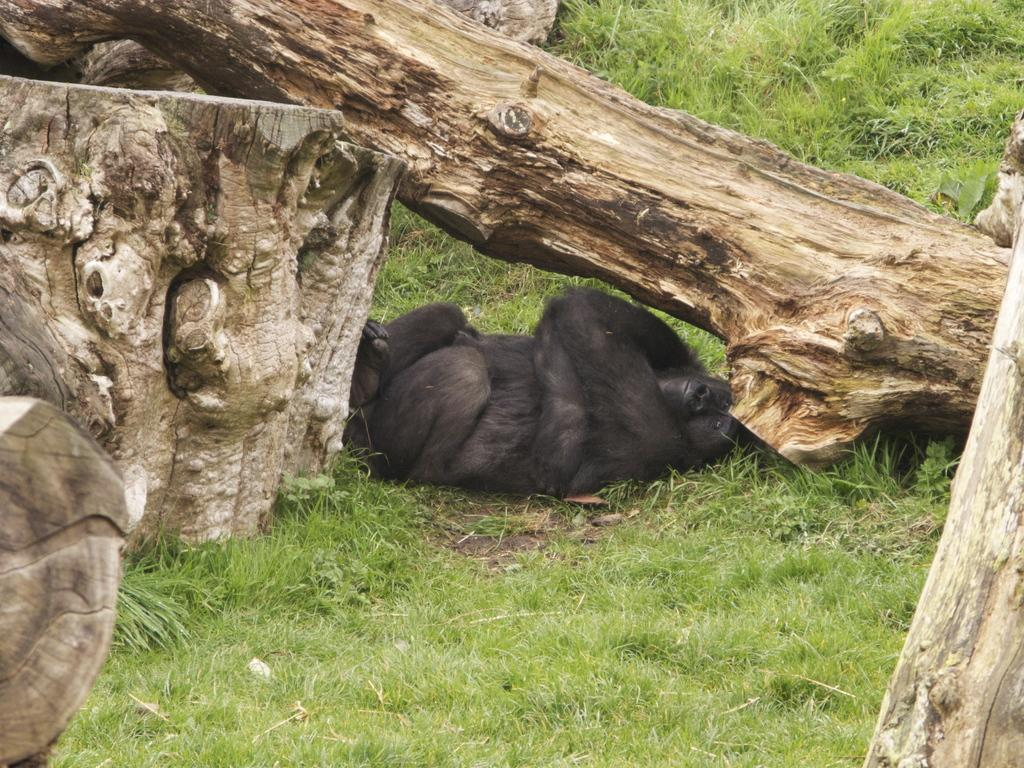What type of animal can be seen in the image? There is an animal in the image, but its specific type cannot be determined from the provided facts. What color is the animal in the image? The animal is black in color. Where is the animal located in the image? The animal is lying under a wooden log. What other wooden objects can be seen in the image? There are additional wooden logs visible in the image. What type of vegetation is present in the image? Grass is present in the image. What decision does the animal make while lying under the wooden log in the image? There is no indication in the image that the animal is making any decisions while lying under the wooden log. 